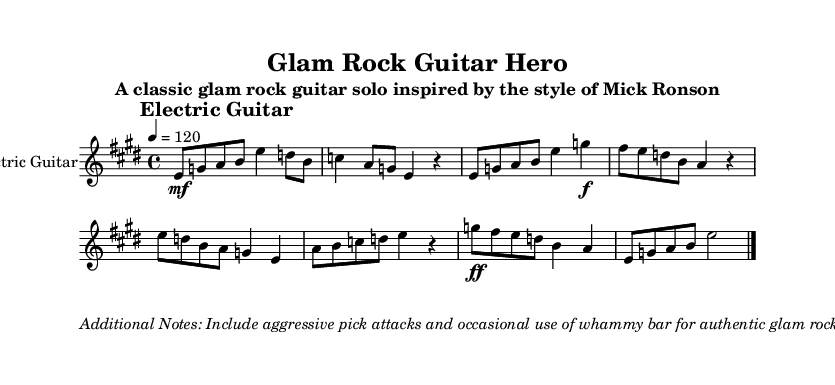What is the key signature of this music? The key signature is E major, which has four sharps (F#, C#, G#, D#). This can be determined from the key signature indicated at the beginning of the sheet music.
Answer: E major What is the time signature of this music? The time signature is 4/4, meaning there are four beats in each measure and the quarter note receives one beat. This is clearly marked at the beginning of the piece.
Answer: 4/4 What is the tempo marking? The tempo marking is 120 beats per minute, indicated by the "4 = 120" notation at the beginning. This tells the performer how fast the music should be played.
Answer: 120 How many measures are in the guitar solo? The guitar solo contains 8 measures, as counted from the start to the end of the music. Each measure is separated by vertical lines in the sheet music.
Answer: 8 What techniques are specified for the guitar part? The specified techniques include bends, slides, vibrato, and palm muting. These are listed as additional information in the markup section of the sheet music.
Answer: Bends, slides, vibrato, palm muting What is the last note of the guitar solo? The last note of the guitar solo is E, which is found at the end of the last measure in the solo line. It is indicated by the note on the staff just before the final bar line.
Answer: E What additional flavor is suggested for the solo? The additional flavor suggested includes aggressive pick attacks and occasional use of the whammy bar. This directive aims to capture the authentic sound of glam rock.
Answer: Aggressive pick attacks, whammy bar 